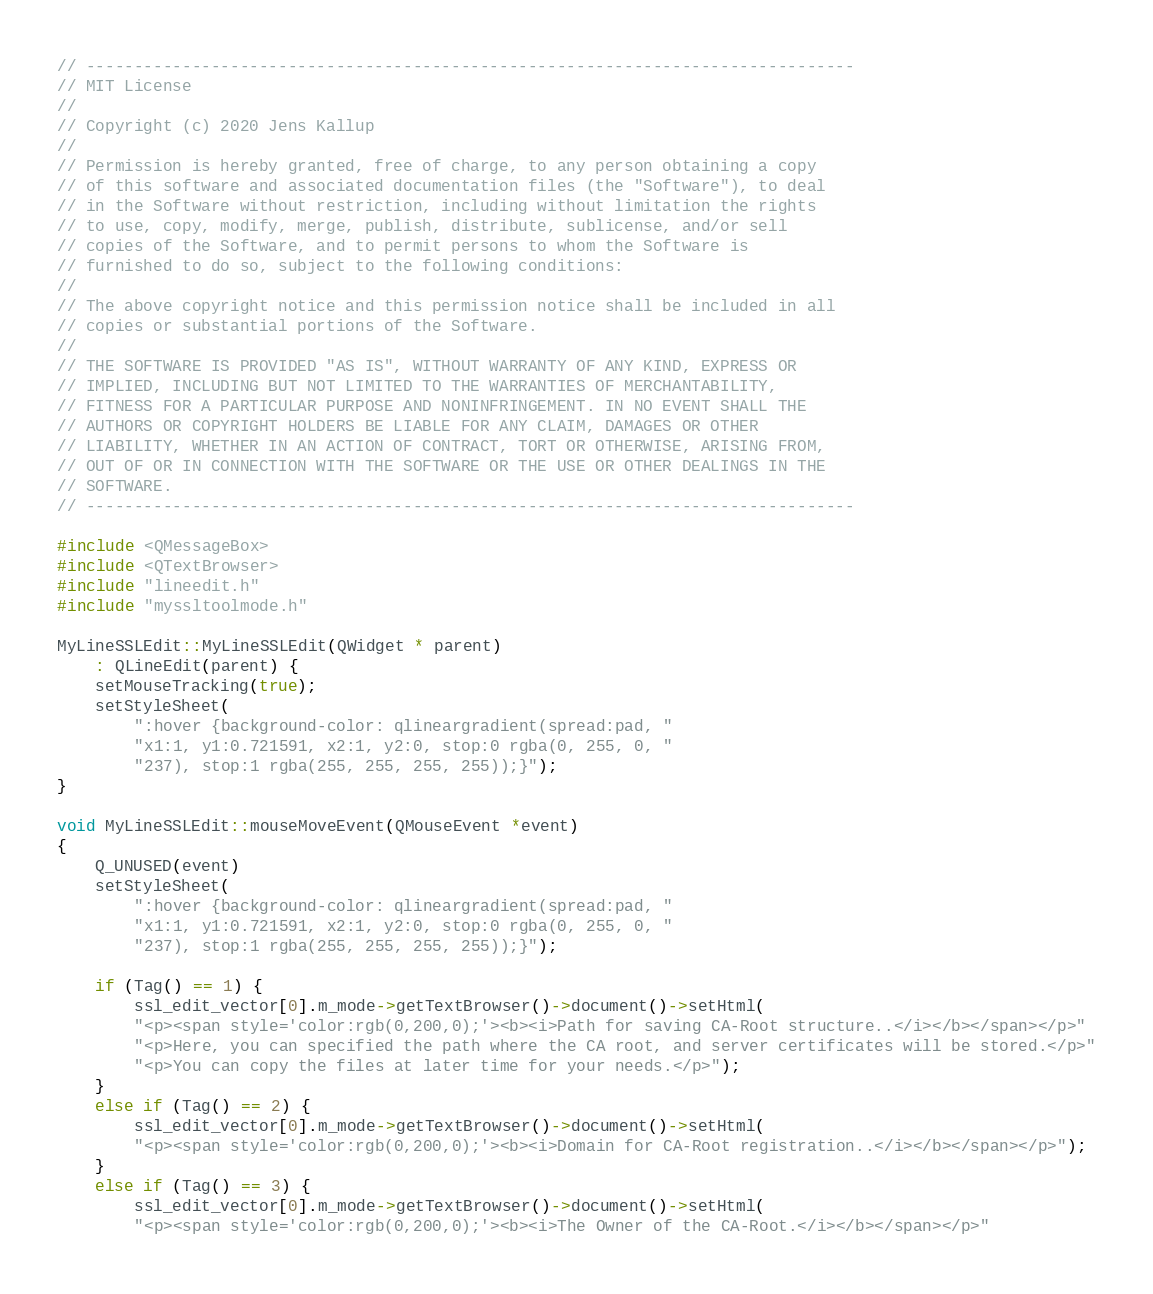Convert code to text. <code><loc_0><loc_0><loc_500><loc_500><_C++_>// --------------------------------------------------------------------------------
// MIT License
//
// Copyright (c) 2020 Jens Kallup
//
// Permission is hereby granted, free of charge, to any person obtaining a copy
// of this software and associated documentation files (the "Software"), to deal
// in the Software without restriction, including without limitation the rights
// to use, copy, modify, merge, publish, distribute, sublicense, and/or sell
// copies of the Software, and to permit persons to whom the Software is
// furnished to do so, subject to the following conditions:
//
// The above copyright notice and this permission notice shall be included in all
// copies or substantial portions of the Software.
//
// THE SOFTWARE IS PROVIDED "AS IS", WITHOUT WARRANTY OF ANY KIND, EXPRESS OR
// IMPLIED, INCLUDING BUT NOT LIMITED TO THE WARRANTIES OF MERCHANTABILITY,
// FITNESS FOR A PARTICULAR PURPOSE AND NONINFRINGEMENT. IN NO EVENT SHALL THE
// AUTHORS OR COPYRIGHT HOLDERS BE LIABLE FOR ANY CLAIM, DAMAGES OR OTHER
// LIABILITY, WHETHER IN AN ACTION OF CONTRACT, TORT OR OTHERWISE, ARISING FROM,
// OUT OF OR IN CONNECTION WITH THE SOFTWARE OR THE USE OR OTHER DEALINGS IN THE
// SOFTWARE.
// --------------------------------------------------------------------------------

#include <QMessageBox>
#include <QTextBrowser>
#include "lineedit.h"
#include "myssltoolmode.h"

MyLineSSLEdit::MyLineSSLEdit(QWidget * parent)
    : QLineEdit(parent) {
    setMouseTracking(true);
    setStyleSheet(
        ":hover {background-color: qlineargradient(spread:pad, "
        "x1:1, y1:0.721591, x2:1, y2:0, stop:0 rgba(0, 255, 0, "
        "237), stop:1 rgba(255, 255, 255, 255));}");
}

void MyLineSSLEdit::mouseMoveEvent(QMouseEvent *event)
{
    Q_UNUSED(event)
    setStyleSheet(
        ":hover {background-color: qlineargradient(spread:pad, "
        "x1:1, y1:0.721591, x2:1, y2:0, stop:0 rgba(0, 255, 0, "
        "237), stop:1 rgba(255, 255, 255, 255));}");

    if (Tag() == 1) {
        ssl_edit_vector[0].m_mode->getTextBrowser()->document()->setHtml(
        "<p><span style='color:rgb(0,200,0);'><b><i>Path for saving CA-Root structure..</i></b></span></p>"
        "<p>Here, you can specified the path where the CA root, and server certificates will be stored.</p>"
        "<p>You can copy the files at later time for your needs.</p>");
    }
    else if (Tag() == 2) {
        ssl_edit_vector[0].m_mode->getTextBrowser()->document()->setHtml(
        "<p><span style='color:rgb(0,200,0);'><b><i>Domain for CA-Root registration..</i></b></span></p>");
    }
    else if (Tag() == 3) {
        ssl_edit_vector[0].m_mode->getTextBrowser()->document()->setHtml(
        "<p><span style='color:rgb(0,200,0);'><b><i>The Owner of the CA-Root.</i></b></span></p>"</code> 